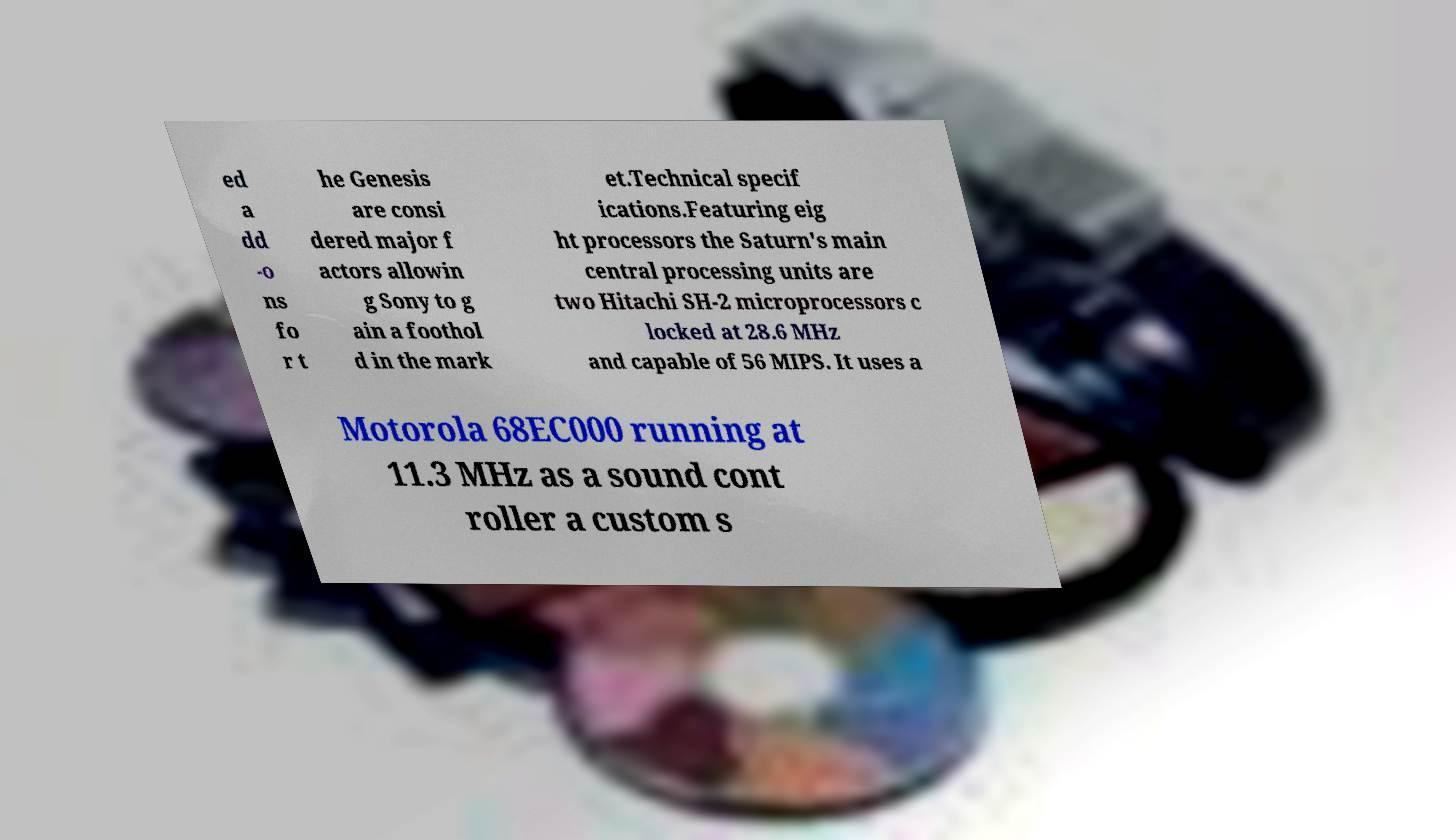Please identify and transcribe the text found in this image. ed a dd -o ns fo r t he Genesis are consi dered major f actors allowin g Sony to g ain a foothol d in the mark et.Technical specif ications.Featuring eig ht processors the Saturn's main central processing units are two Hitachi SH-2 microprocessors c locked at 28.6 MHz and capable of 56 MIPS. It uses a Motorola 68EC000 running at 11.3 MHz as a sound cont roller a custom s 